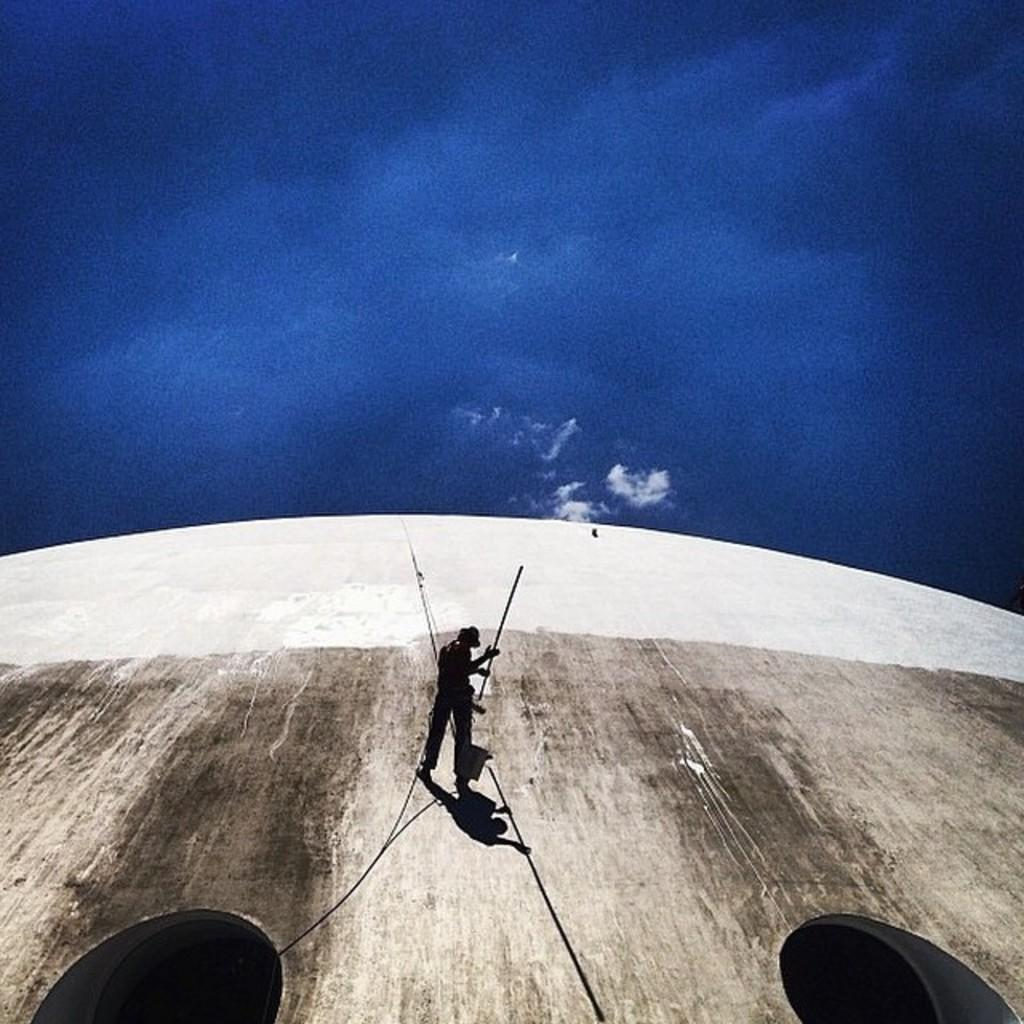What is depicted on the wall in the image? There is a man on the wall in the image. What is the man holding in the image? The man is holding a stick. What can be seen at the bottom of the image? There are two holes at the bottom of the image. What is visible in the background of the image? The sky is visible in the background of the image. How many spiders are crawling on the man's face in the image? There are no spiders present in the image; it only features a man holding a stick on a wall. What type of muscle is being exercised by the man in the image? There is no indication of muscle exercise in the image, as it only shows a man holding a stick on a wall. 